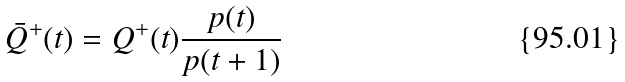Convert formula to latex. <formula><loc_0><loc_0><loc_500><loc_500>\bar { Q } ^ { + } ( t ) = Q ^ { + } ( t ) \frac { p ( t ) } { p ( t + 1 ) }</formula> 